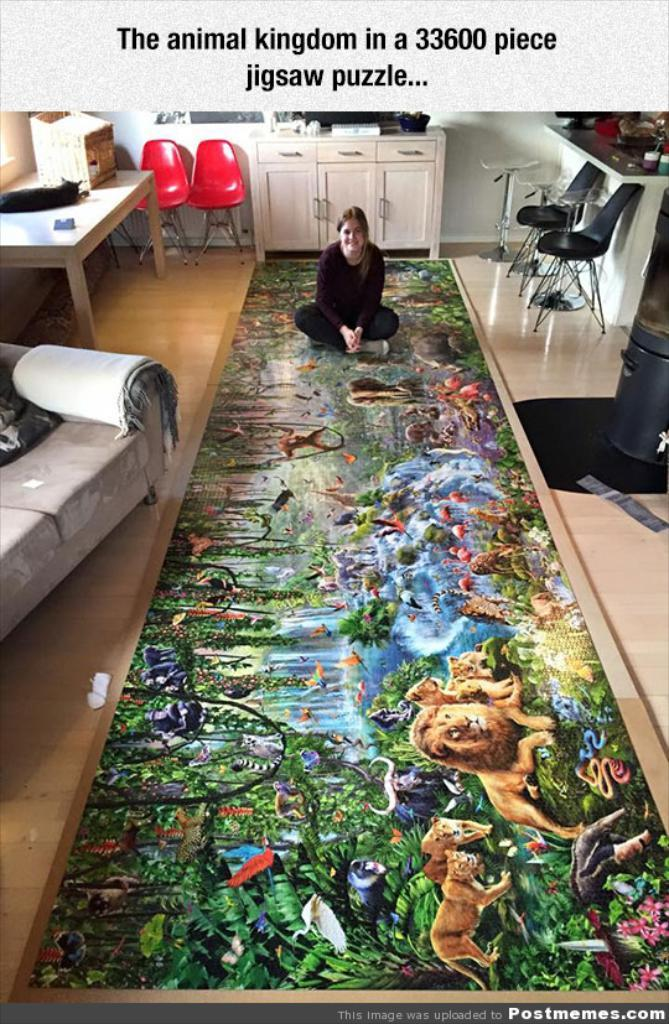What is the person in the image doing? The person is sitting on a carpet in the image. Can you describe the carpet? The carpet is colorful. What other furniture can be seen in the room? There is a couch, a table, chairs, and a cupboard in the room. Is there any other item in the room related to waste disposal? Yes, there is a dustbin in the room. What type of skate is the person wearing in the image? There is no skate present in the image; the person is sitting on a carpet. Can you tell me what time the person is watching on their watch in the image? There is no watch present in the image, and the person's activity is not specified as watching something. 